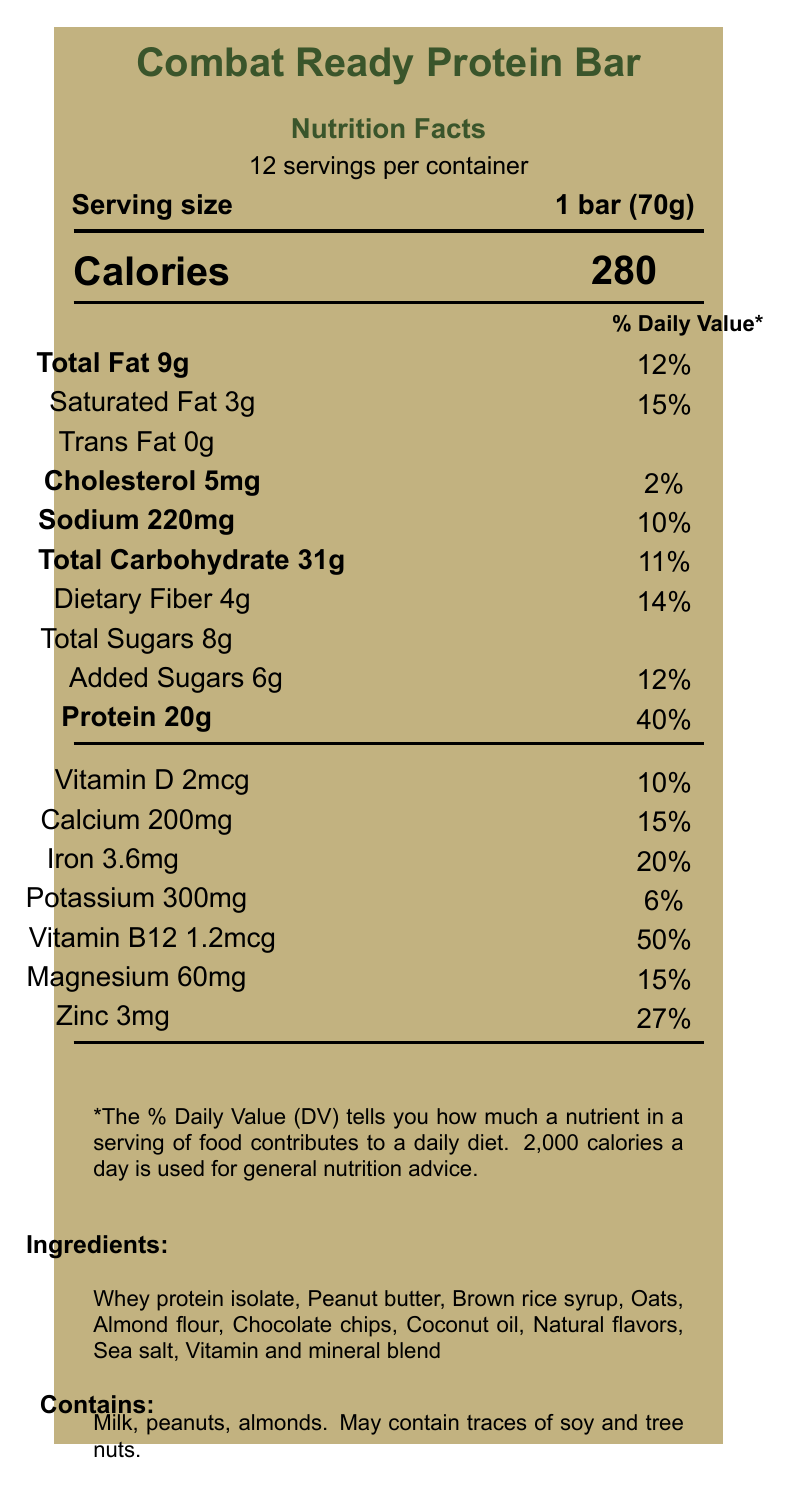what is the serving size? The serving size is clearly stated in the document as "1 bar (70g)".
Answer: 1 bar (70g) how many servings per container are there? The document specifies that there are 12 servings per container.
Answer: 12 how many calories are in one serving? The number of calories per serving is listed as 280.
Answer: 280 what is the total fat content in one bar? The total fat content per serving is listed as 9g.
Answer: 9g how much protein does one bar contain? The protein content per bar is stated as 20g.
Answer: 20g which of the following vitamins is present in the highest percentage of the daily value? A. Vitamin D B. Calcium C. Vitamin B12 D. Magnesium The daily value of Vitamin B12 is listed as 50%, which is the highest among the options.
Answer: C which ingredient is not listed in the ingredients section? A. Whey protein isolate B. Peanut butter C. Brown rice syrup D. Soy The document does not list soy as an ingredient, though it mentions traces of soy may be present.
Answer: D is this product a good source of fiber? The product claims it is a "good source of fiber," and the daily value for dietary fiber is 14%, supporting this claim.
Answer: Yes does this product contain trans fat? The document lists trans fat content as 0g.
Answer: No summarize the main information provided in the document. The document provides nutritional information for a protein bar, detailing its contents, allergens, serving size, and suitability for military training.
Answer: The document is a Nutrition Facts Label for the "Combat Ready Protein Bar," which is high in protein and suitable for Army Reserve training. It lists serving size, nutritional content, ingredients, allergens, and some product claims. who is the manufacturer of this product? The manufacturer is mentioned as TactiCal Nutrition, Inc.
Answer: TactiCal Nutrition, Inc. what are the storage instructions for this product? The label states, "Store in a cool, dry place. Ideal for field exercises and high-intensity training."
Answer: Store in a cool, dry place. how much added sugar does one bar contain? The amount of added sugars per serving is listed as 6g.
Answer: 6g name two allergens mentioned in the document. The document mentions that the product contains milk and peanuts.
Answer: Milk, peanuts how much vitamin D is in one serving? The content of vitamin D per serving is listed as 2mcg.
Answer: 2mcg can I determine the expiration date of the product from the document? The document does not provide any information regarding the expiration date of the product.
Answer: Not enough information 